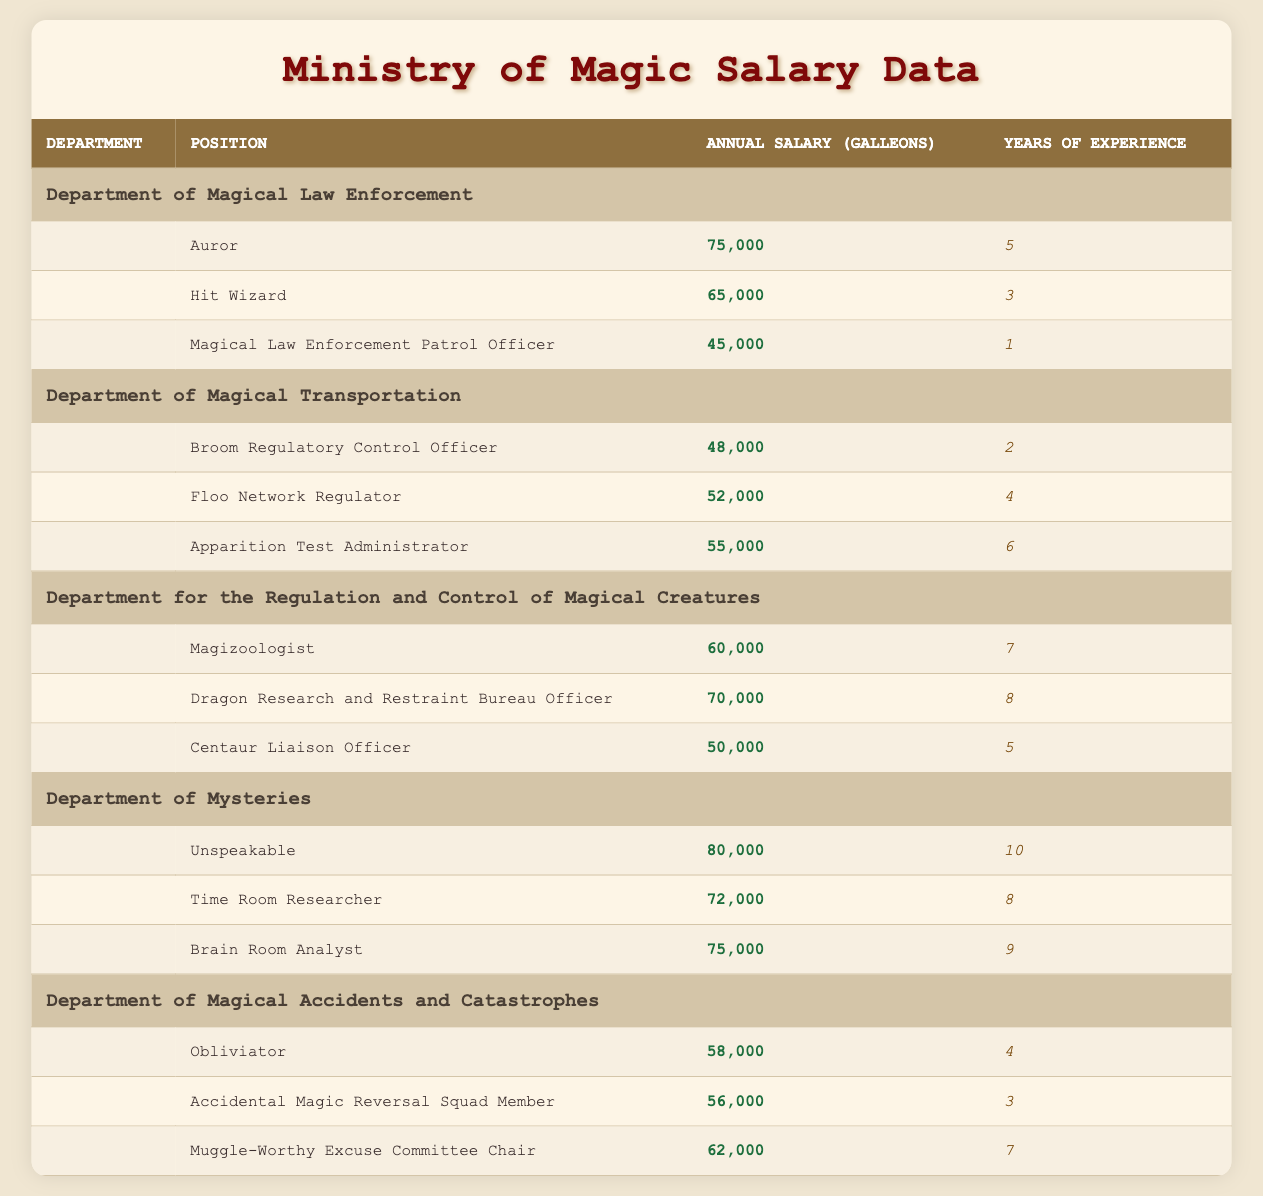What is the highest annual salary in the Department of Mysteries? The table shows that the Unspeakable has the highest annual salary in the Department of Mysteries, which is 80,000 Galleons.
Answer: 80,000 How much does a Dragon Research and Restraint Bureau Officer make compared to a Centaur Liaison Officer? The annual salary of a Dragon Research and Restraint Bureau Officer is 70,000 Galleons, while a Centaur Liaison Officer makes 50,000 Galleons. Therefore, the Dragon Research and Restraint Bureau Officer earns 20,000 Galleons more.
Answer: 20,000 Is it true that all positions in the Department of Magical Law Enforcement earn over 60,000 Galleons? The Auror and Hit Wizard earn more than 60,000 Galleons, but the Magical Law Enforcement Patrol Officer earns only 45,000 Galleons. Thus, the statement is false.
Answer: False What is the total annual salary of all positions in the Department for the Regulation and Control of Magical Creatures? To find this total, add the salaries of the three positions: 60,000 (Magizoologist) + 70,000 (Dragon Research and Restraint Bureau Officer) + 50,000 (Centaur Liaison Officer) = 180,000 Galleons.
Answer: 180,000 Which department has the position with the least years of experience required? In the Department of Magical Law Enforcement, the Magical Law Enforcement Patrol Officer requires only 1 year of experience, which is the least among all positions listed in the table.
Answer: Department of Magical Law Enforcement What is the average annual salary for all positions listed in the Department of Magical Accidents and Catastrophes? The three salaries listed are 58,000 (Obliviator), 56,000 (Accidental Magic Reversal Squad Member), and 62,000 (Muggle-Worthy Excuse Committee Chair). Summing these gives 176,000 Galleons. There are 3 positions, so the average is 176,000 / 3 = 58,667 Galleons.
Answer: 58,667 How many positions in the Department of Magical Transportation earn more than 50,000 Galleons? There are three positions: Broom Regulatory Control Officer (48,000), Floo Network Regulator (52,000), and Apparition Test Administrator (55,000). Only the Floo Network Regulator and Apparition Test Administrator earn more than 50,000, totaling 2 positions.
Answer: 2 Which position has the most years of experience listed, and what is the salary for that position? The position with the most years of experience is the Unspeakable, requiring 10 years and earning a salary of 80,000 Galleons.
Answer: 80,000 